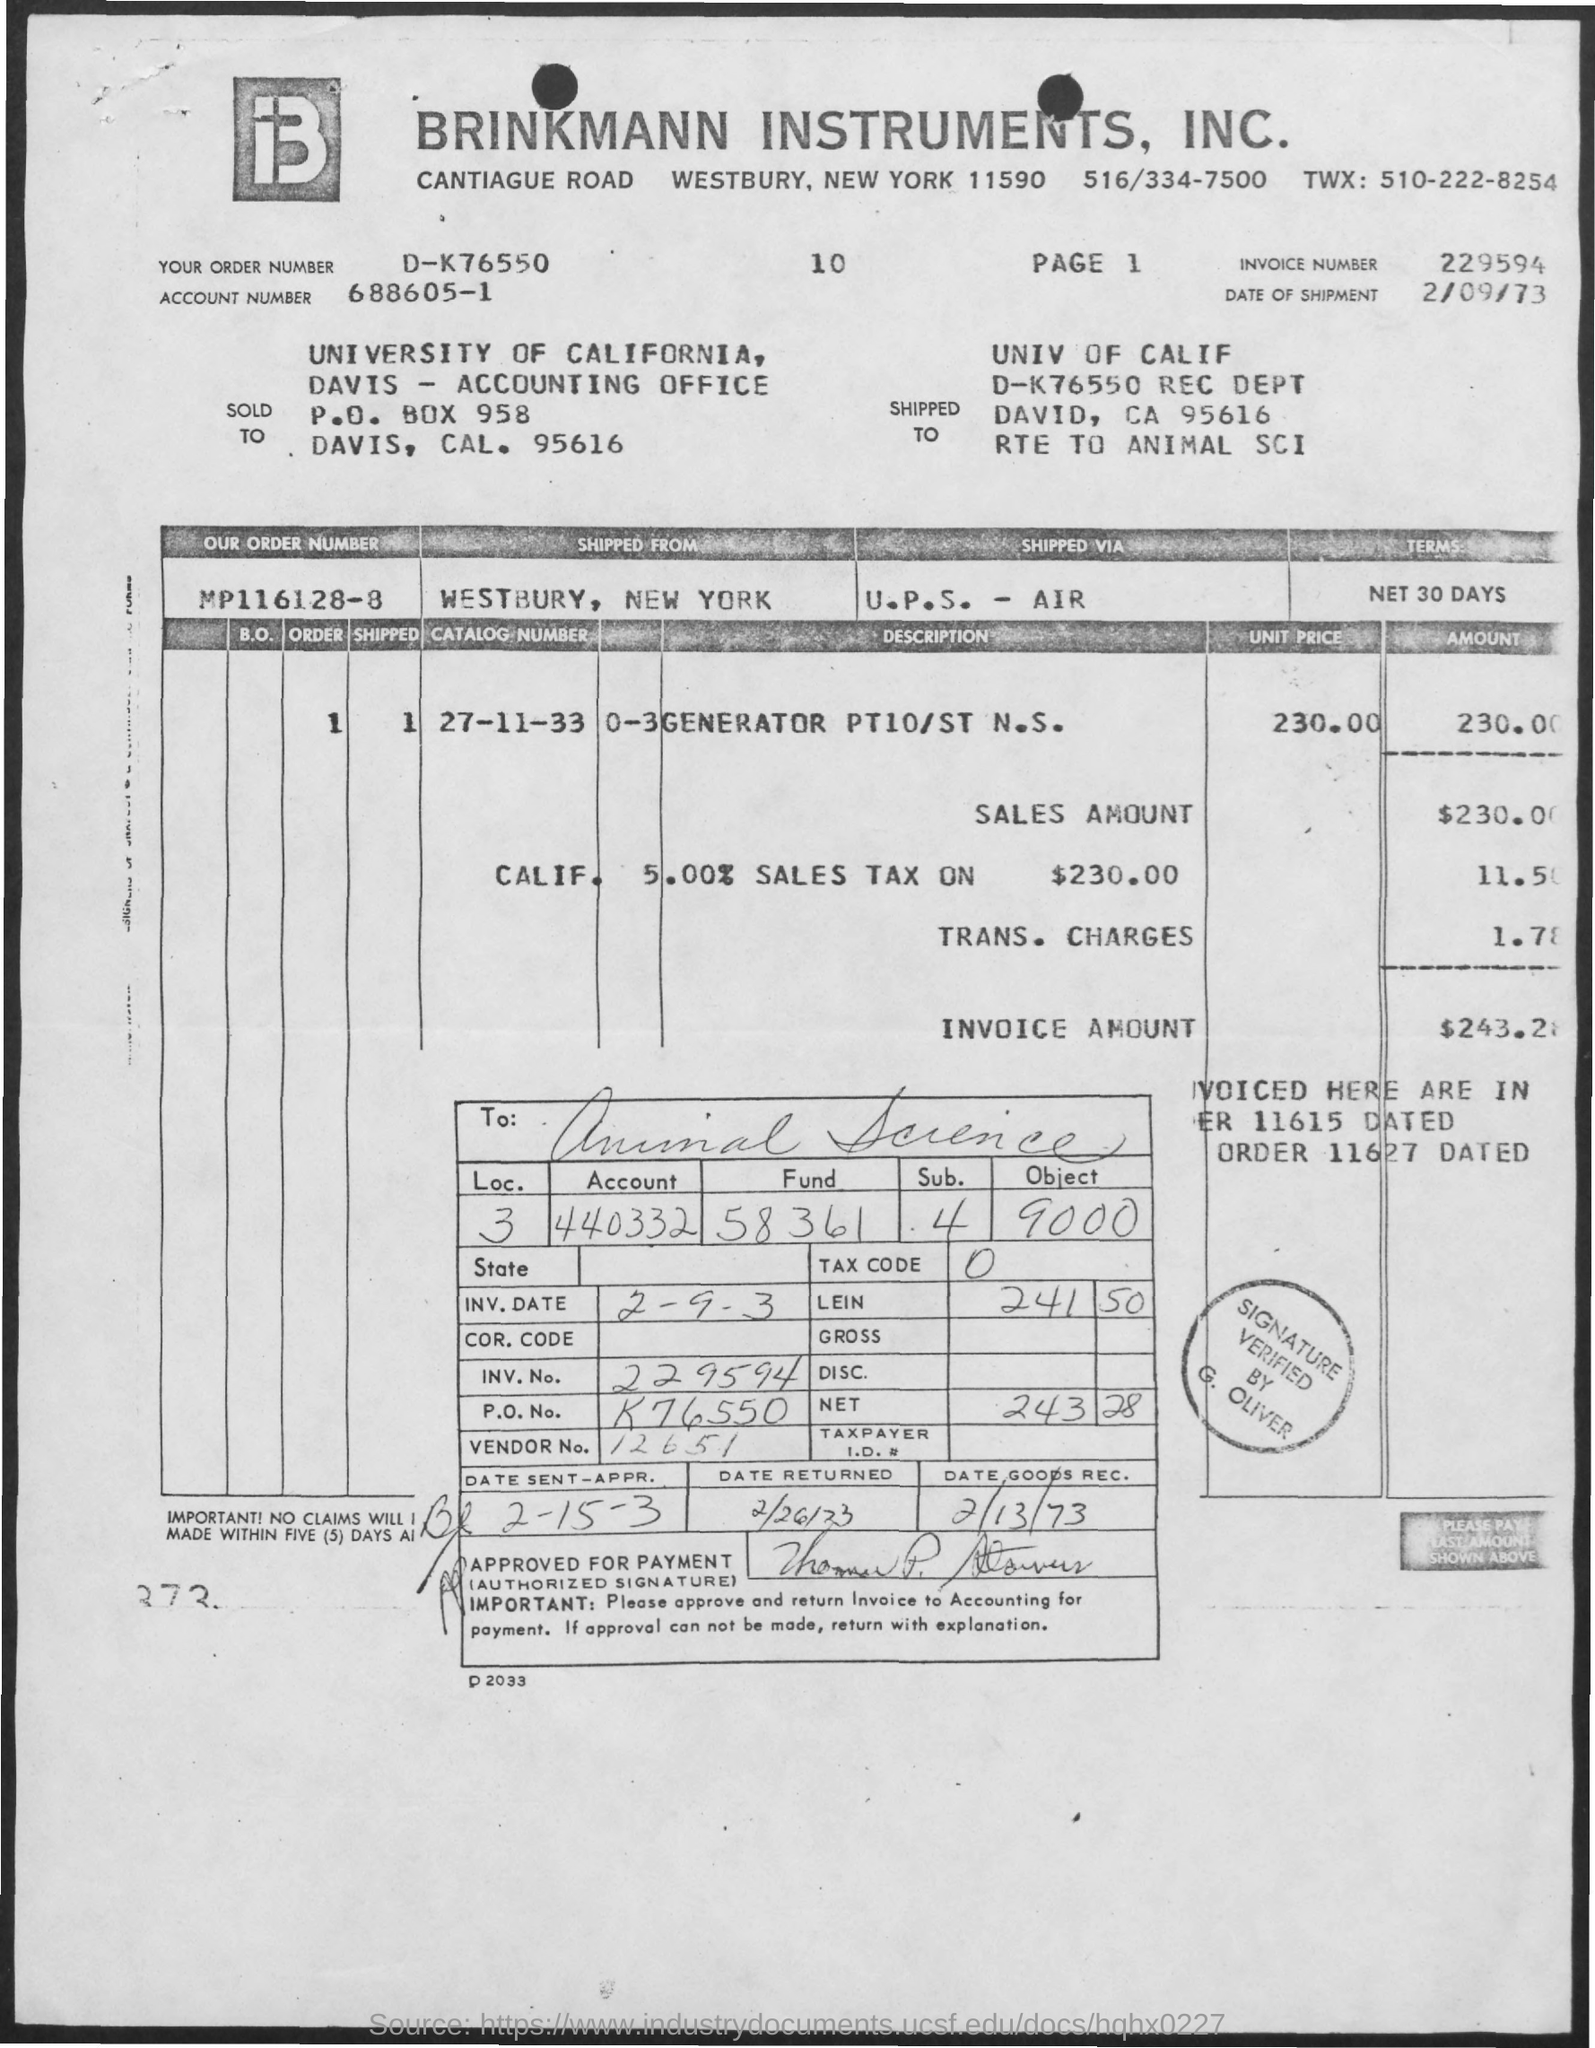What is the name of the university ?
Make the answer very short. Univ of Calif. What is the invoice number ?
Give a very brief answer. 229594. What is the date of shipment ?
Keep it short and to the point. 2/09/73. What is the vendor number ?
Make the answer very short. 12651. What is the date of goods rec?
Ensure brevity in your answer.  2/13/73. 